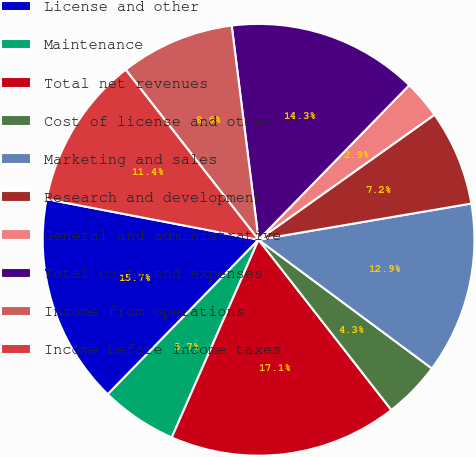<chart> <loc_0><loc_0><loc_500><loc_500><pie_chart><fcel>License and other<fcel>Maintenance<fcel>Total net revenues<fcel>Cost of license and other<fcel>Marketing and sales<fcel>Research and development<fcel>General and administrative<fcel>Total costs and expenses<fcel>Income from operations<fcel>Income before income taxes<nl><fcel>15.71%<fcel>5.72%<fcel>17.13%<fcel>4.29%<fcel>12.85%<fcel>7.15%<fcel>2.87%<fcel>14.28%<fcel>8.57%<fcel>11.43%<nl></chart> 